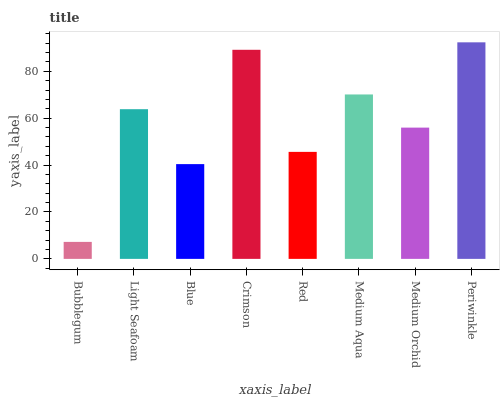Is Light Seafoam the minimum?
Answer yes or no. No. Is Light Seafoam the maximum?
Answer yes or no. No. Is Light Seafoam greater than Bubblegum?
Answer yes or no. Yes. Is Bubblegum less than Light Seafoam?
Answer yes or no. Yes. Is Bubblegum greater than Light Seafoam?
Answer yes or no. No. Is Light Seafoam less than Bubblegum?
Answer yes or no. No. Is Light Seafoam the high median?
Answer yes or no. Yes. Is Medium Orchid the low median?
Answer yes or no. Yes. Is Bubblegum the high median?
Answer yes or no. No. Is Periwinkle the low median?
Answer yes or no. No. 